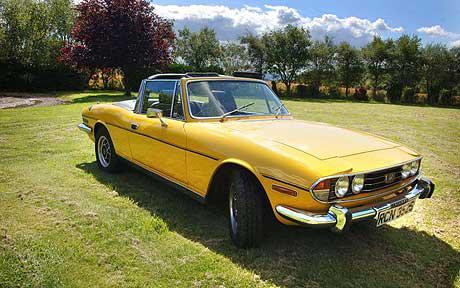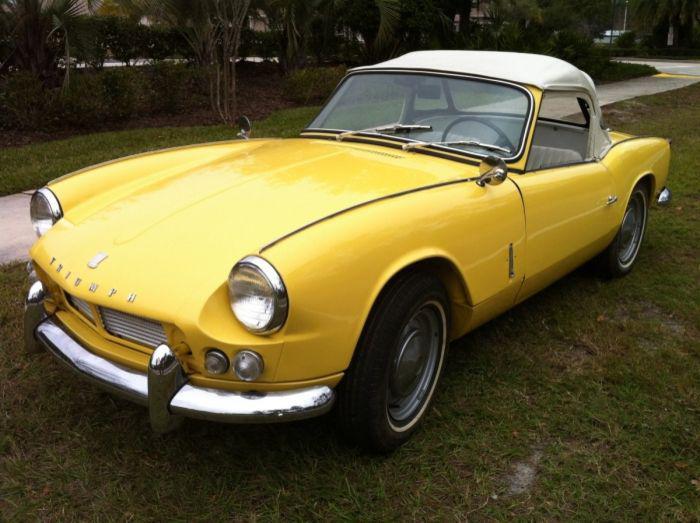The first image is the image on the left, the second image is the image on the right. Assess this claim about the two images: "An image shows a horizontal parked red convertible with its black top covering it.". Correct or not? Answer yes or no. No. The first image is the image on the left, the second image is the image on the right. Analyze the images presented: Is the assertion "There are two yellow cars parked on grass." valid? Answer yes or no. Yes. 